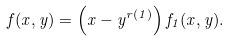Convert formula to latex. <formula><loc_0><loc_0><loc_500><loc_500>f ( x , y ) = \left ( x - y ^ { r ( 1 ) } \right ) f _ { 1 } ( x , y ) .</formula> 